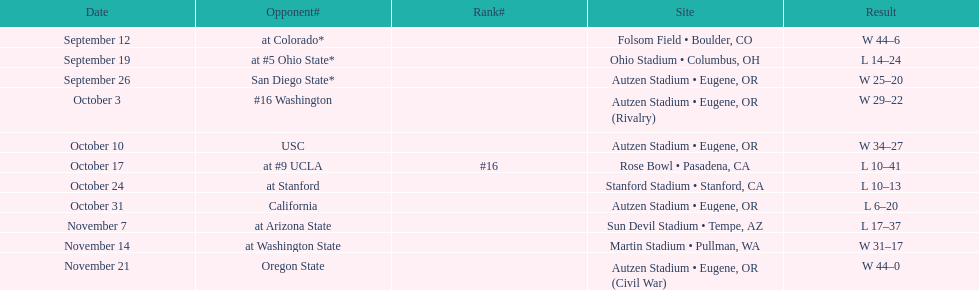How many games were held in eugene, or between september 26 and october 24? 3. 